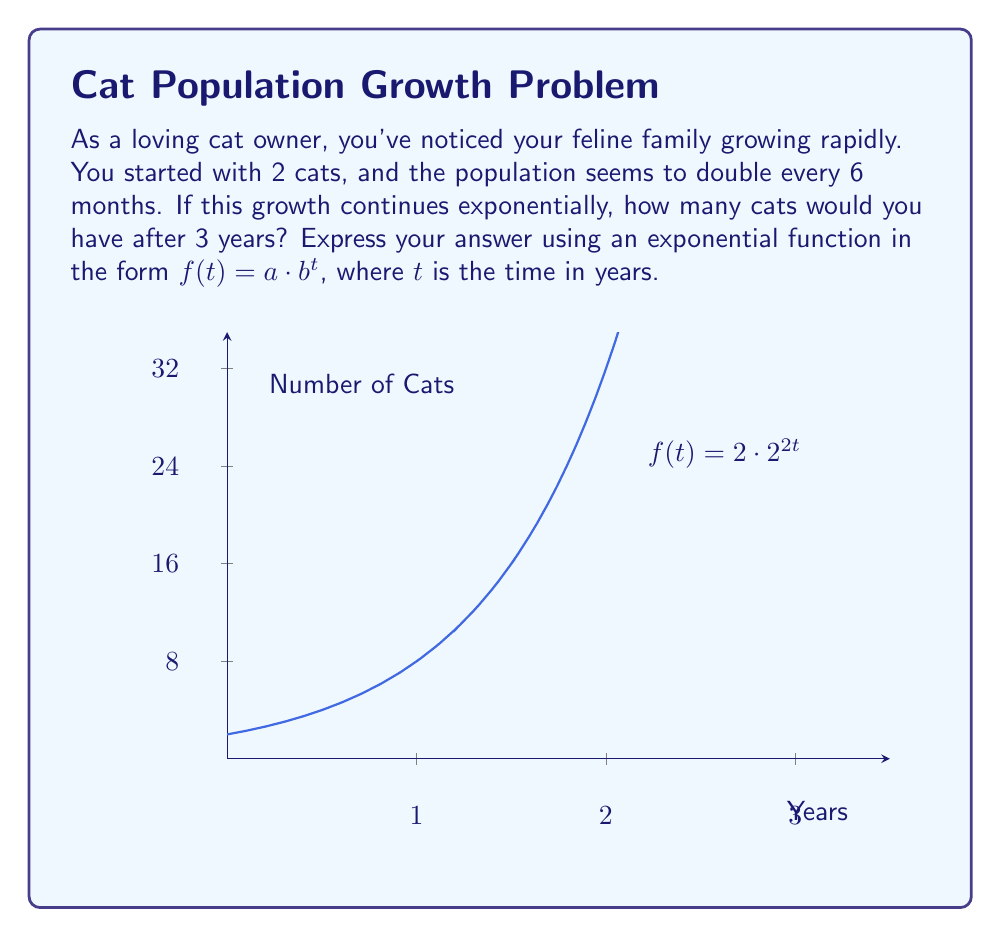Help me with this question. Let's approach this step-by-step:

1) We start with the general form of an exponential function: $f(t) = a \cdot b^t$

2) We know:
   - Initial number of cats, $a = 2$
   - The population doubles every 6 months, or 0.5 years
   - We need to find the number of cats after 3 years

3) To find $b$, we use the fact that the population doubles every 0.5 years:
   $2 = b^{0.5}$
   $b = 2^2 = 4$

4) Now we have: $f(t) = 2 \cdot 4^t$

5) We can simplify this further:
   $f(t) = 2 \cdot (2^2)^t = 2 \cdot 2^{2t}$

6) Therefore, our final exponential function is:
   $f(t) = 2 \cdot 2^{2t}$

7) To find the number of cats after 3 years, we calculate $f(3)$:
   $f(3) = 2 \cdot 2^{2(3)} = 2 \cdot 2^6 = 2 \cdot 64 = 128$

Thus, after 3 years, you would have 128 cats if this exponential growth continued.
Answer: $f(t) = 2 \cdot 2^{2t}$ 